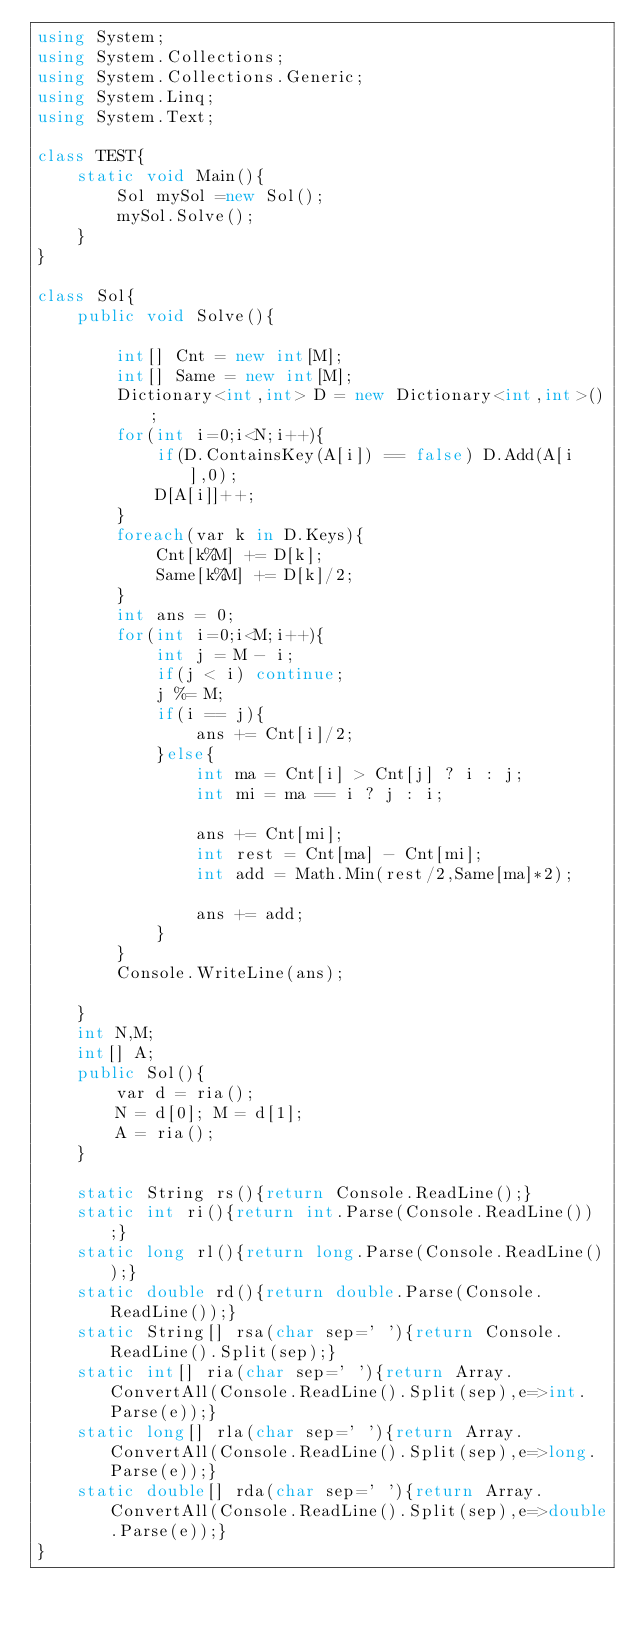Convert code to text. <code><loc_0><loc_0><loc_500><loc_500><_C#_>using System;
using System.Collections;
using System.Collections.Generic;
using System.Linq;
using System.Text;

class TEST{
	static void Main(){
		Sol mySol =new Sol();
		mySol.Solve();
	}
}

class Sol{
	public void Solve(){
		
		int[] Cnt = new int[M];
		int[] Same = new int[M];
		Dictionary<int,int> D = new Dictionary<int,int>();
		for(int i=0;i<N;i++){
			if(D.ContainsKey(A[i]) == false) D.Add(A[i],0);
			D[A[i]]++;
		}
		foreach(var k in D.Keys){
			Cnt[k%M] += D[k];
			Same[k%M] += D[k]/2;
		}
		int ans = 0;
		for(int i=0;i<M;i++){
			int j = M - i;
			if(j < i) continue;
			j %= M;
			if(i == j){
				ans += Cnt[i]/2;
			}else{
				int ma = Cnt[i] > Cnt[j] ? i : j;
				int mi = ma == i ? j : i;
				
				ans += Cnt[mi];
				int rest = Cnt[ma] - Cnt[mi];
				int add = Math.Min(rest/2,Same[ma]*2);
				
				ans += add;
			}
		}
		Console.WriteLine(ans);
		
	}
	int N,M;
	int[] A;
	public Sol(){
		var d = ria();
		N = d[0]; M = d[1];
		A = ria();
	}

	static String rs(){return Console.ReadLine();}
	static int ri(){return int.Parse(Console.ReadLine());}
	static long rl(){return long.Parse(Console.ReadLine());}
	static double rd(){return double.Parse(Console.ReadLine());}
	static String[] rsa(char sep=' '){return Console.ReadLine().Split(sep);}
	static int[] ria(char sep=' '){return Array.ConvertAll(Console.ReadLine().Split(sep),e=>int.Parse(e));}
	static long[] rla(char sep=' '){return Array.ConvertAll(Console.ReadLine().Split(sep),e=>long.Parse(e));}
	static double[] rda(char sep=' '){return Array.ConvertAll(Console.ReadLine().Split(sep),e=>double.Parse(e));}
}

</code> 